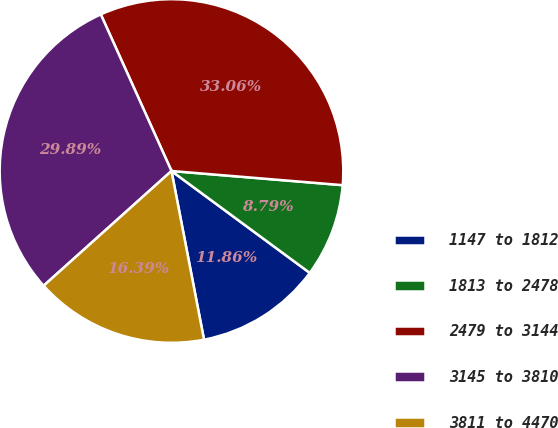<chart> <loc_0><loc_0><loc_500><loc_500><pie_chart><fcel>1147 to 1812<fcel>1813 to 2478<fcel>2479 to 3144<fcel>3145 to 3810<fcel>3811 to 4470<nl><fcel>11.86%<fcel>8.79%<fcel>33.06%<fcel>29.89%<fcel>16.39%<nl></chart> 